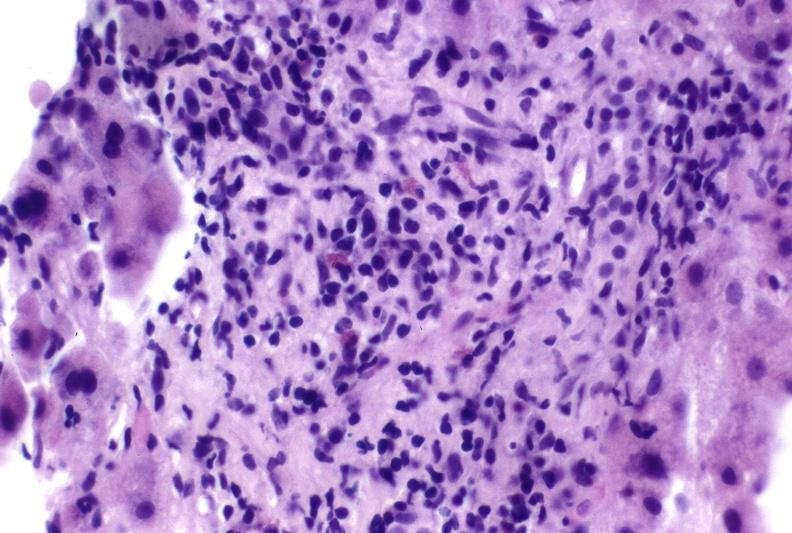s hepatobiliary present?
Answer the question using a single word or phrase. Yes 